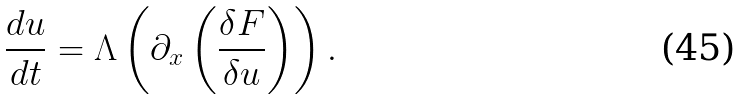Convert formula to latex. <formula><loc_0><loc_0><loc_500><loc_500>\frac { d u } { d t } = \Lambda \left ( \partial _ { x } \left ( \frac { \delta F } { \delta u } \right ) \right ) .</formula> 